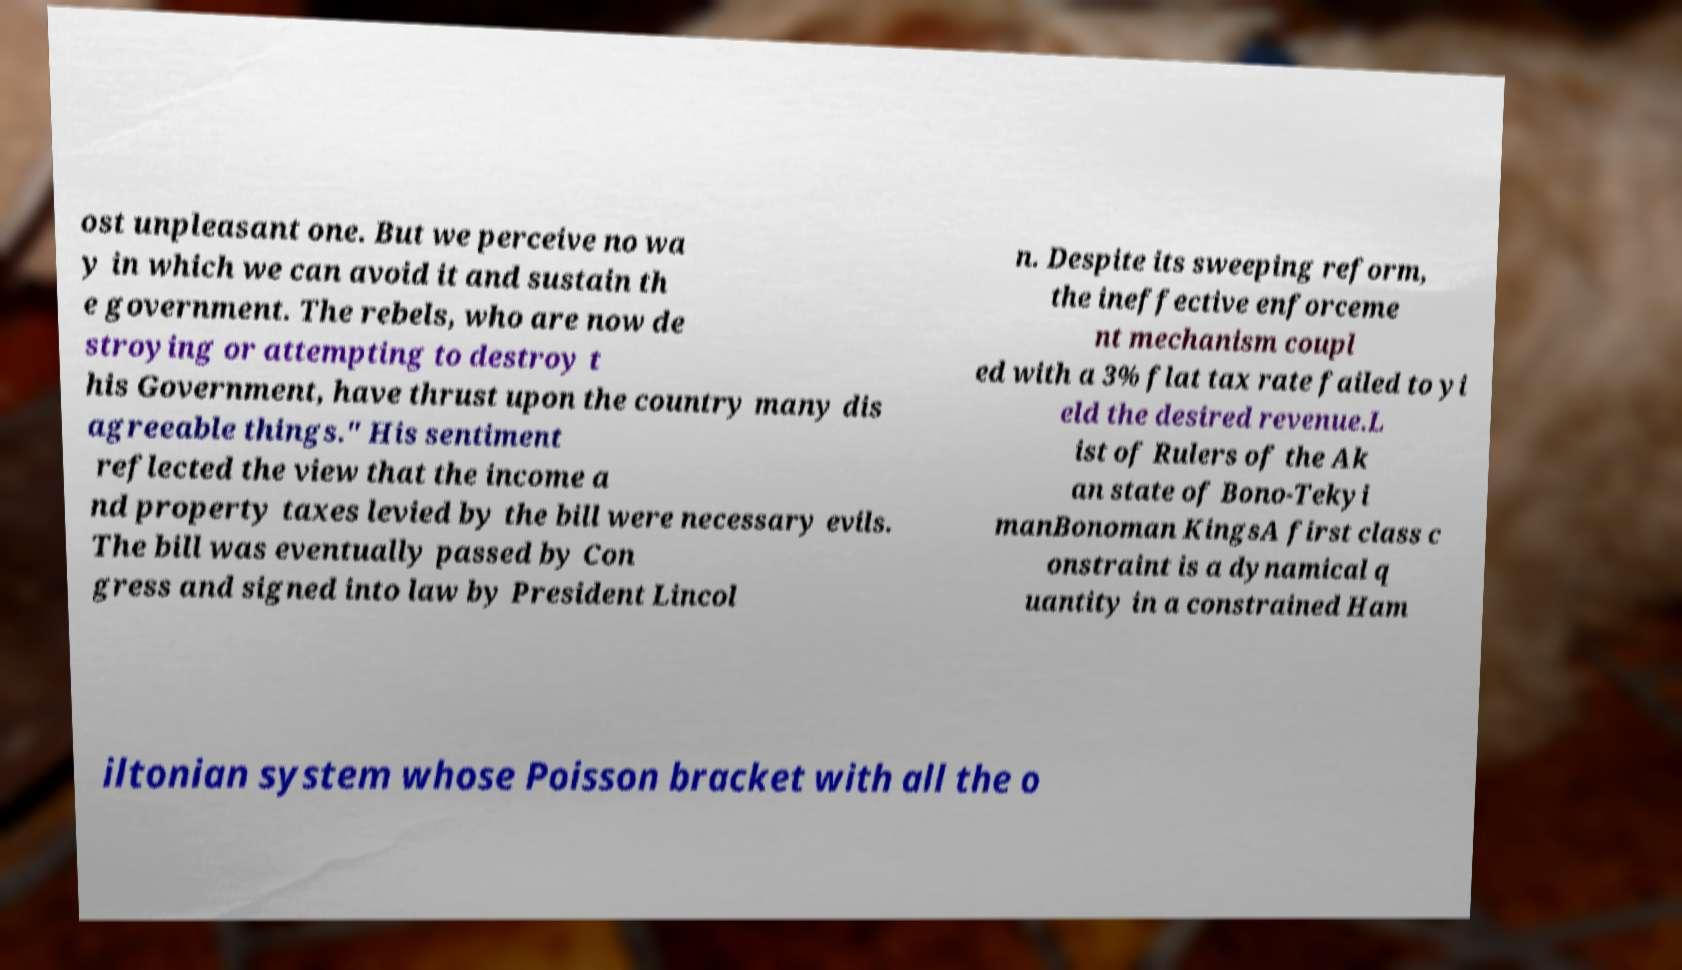Can you accurately transcribe the text from the provided image for me? ost unpleasant one. But we perceive no wa y in which we can avoid it and sustain th e government. The rebels, who are now de stroying or attempting to destroy t his Government, have thrust upon the country many dis agreeable things." His sentiment reflected the view that the income a nd property taxes levied by the bill were necessary evils. The bill was eventually passed by Con gress and signed into law by President Lincol n. Despite its sweeping reform, the ineffective enforceme nt mechanism coupl ed with a 3% flat tax rate failed to yi eld the desired revenue.L ist of Rulers of the Ak an state of Bono-Tekyi manBonoman KingsA first class c onstraint is a dynamical q uantity in a constrained Ham iltonian system whose Poisson bracket with all the o 